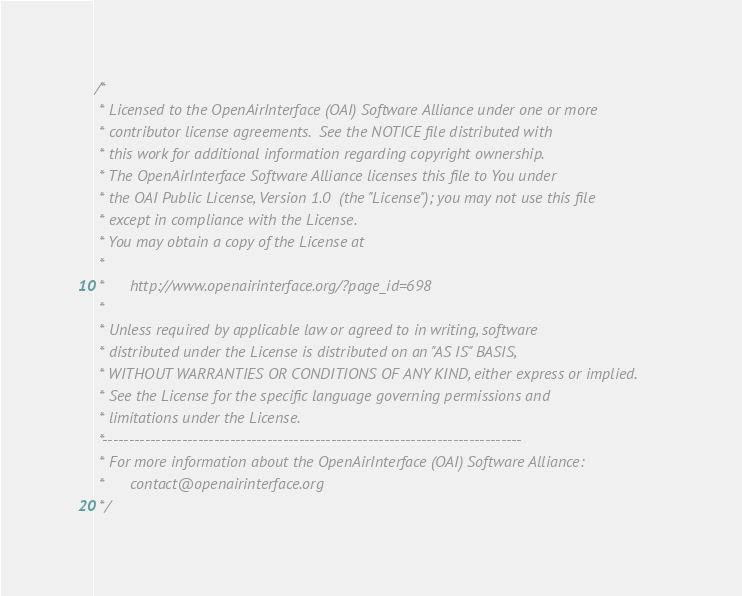<code> <loc_0><loc_0><loc_500><loc_500><_C_>/*
 * Licensed to the OpenAirInterface (OAI) Software Alliance under one or more
 * contributor license agreements.  See the NOTICE file distributed with
 * this work for additional information regarding copyright ownership.
 * The OpenAirInterface Software Alliance licenses this file to You under
 * the OAI Public License, Version 1.0  (the "License"); you may not use this file
 * except in compliance with the License.
 * You may obtain a copy of the License at
 *
 *      http://www.openairinterface.org/?page_id=698
 *
 * Unless required by applicable law or agreed to in writing, software
 * distributed under the License is distributed on an "AS IS" BASIS,
 * WITHOUT WARRANTIES OR CONDITIONS OF ANY KIND, either express or implied.
 * See the License for the specific language governing permissions and
 * limitations under the License.
 *-------------------------------------------------------------------------------
 * For more information about the OpenAirInterface (OAI) Software Alliance:
 *      contact@openairinterface.org
 */
</code> 